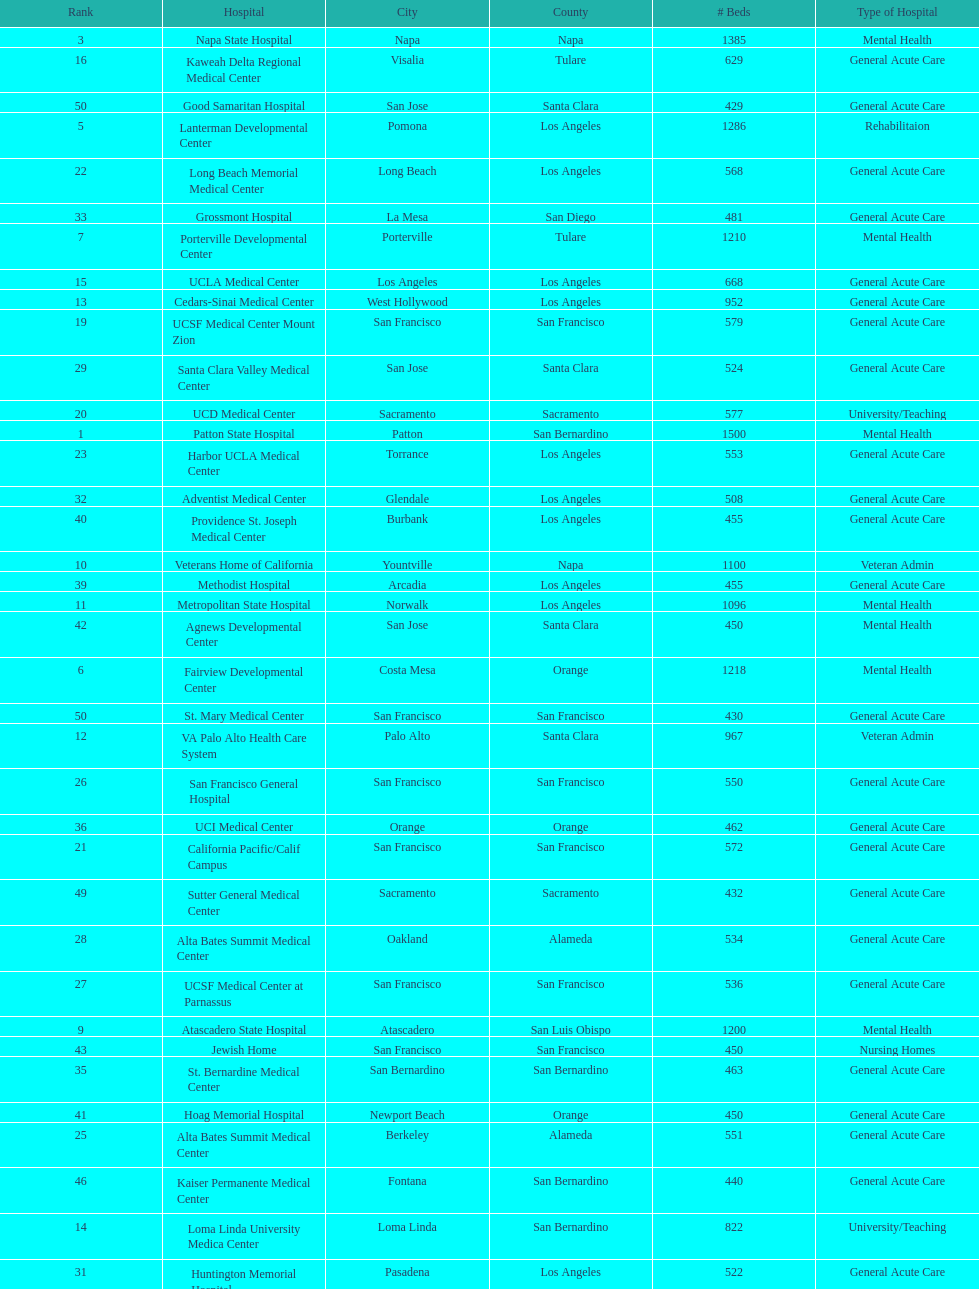Does patton state hospital in the city of patton in san bernardino county have more mental health hospital beds than atascadero state hospital in atascadero, san luis obispo county? Yes. 